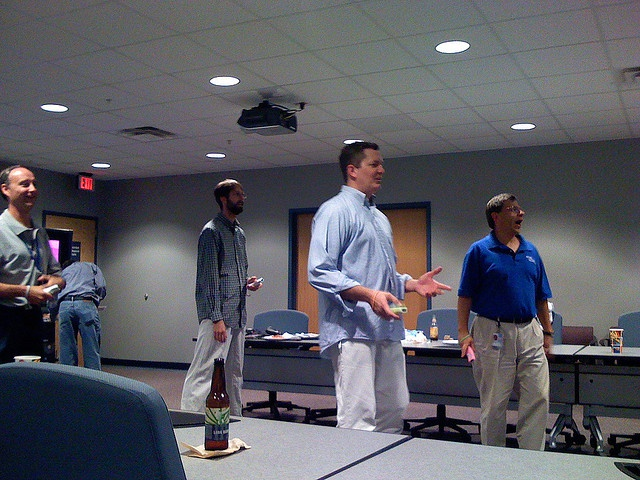Describe the objects in this image and their specific colors. I can see people in gray, lavender, and darkgray tones, people in gray, black, navy, and maroon tones, chair in gray, black, and navy tones, people in gray, black, and darkgray tones, and people in gray, black, darkgray, and navy tones in this image. 